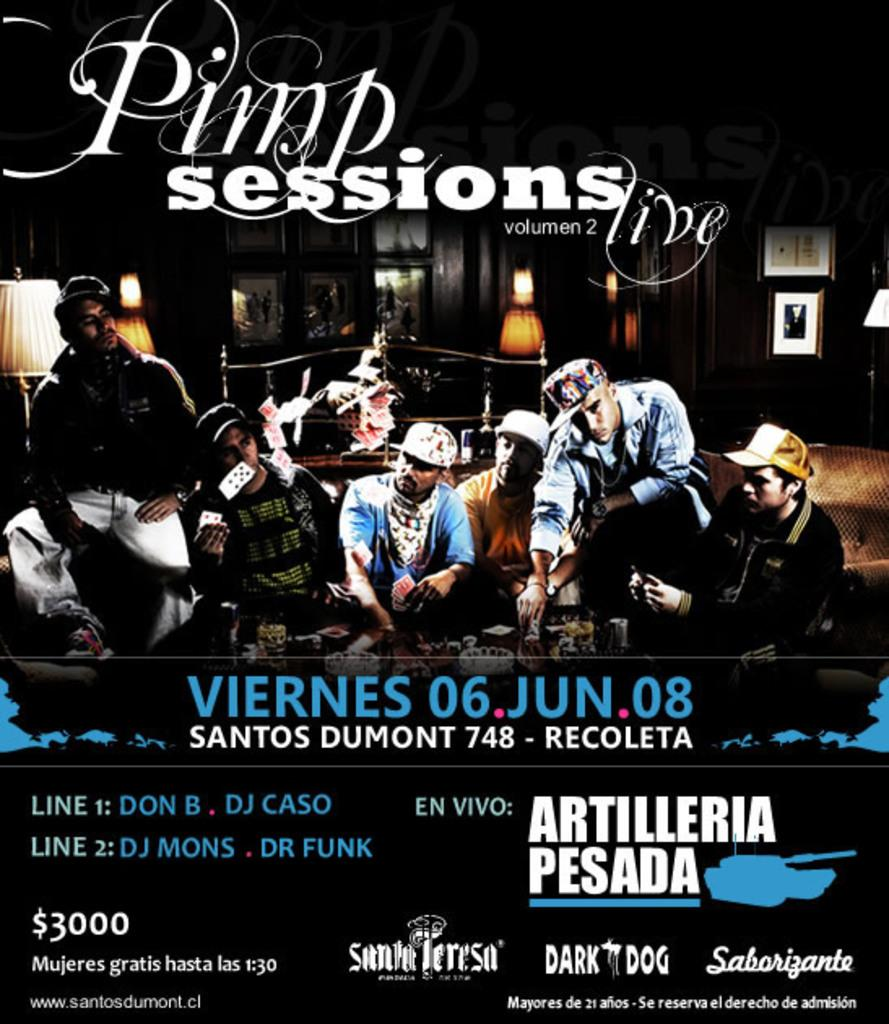<image>
Describe the image concisely. In June 2008 the Pimp Sessions volume 2 album will be available. 